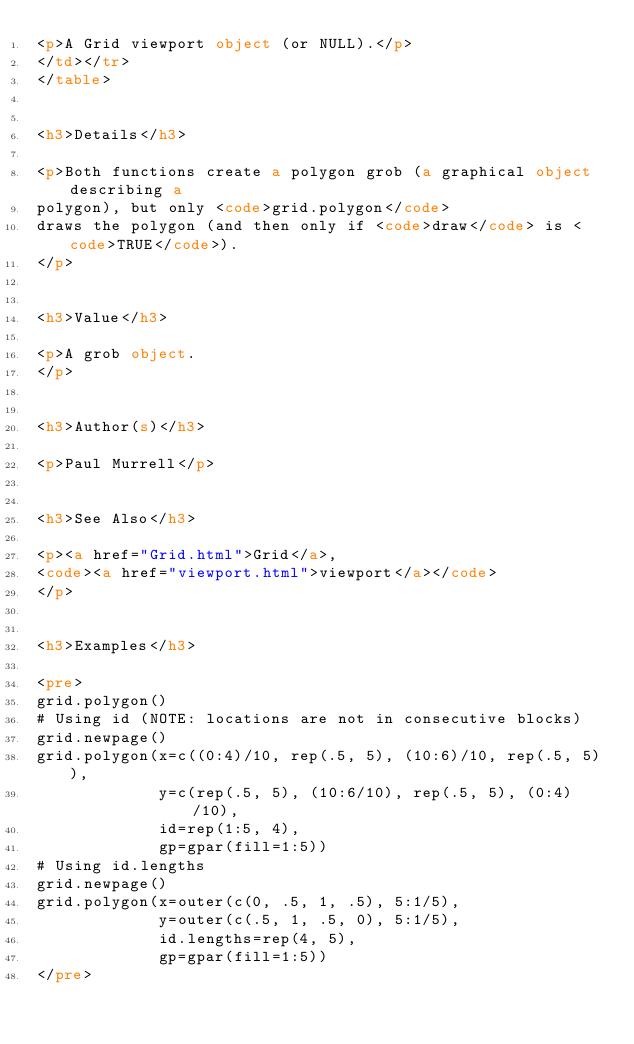Convert code to text. <code><loc_0><loc_0><loc_500><loc_500><_HTML_><p>A Grid viewport object (or NULL).</p>
</td></tr>
</table>


<h3>Details</h3>

<p>Both functions create a polygon grob (a graphical object describing a
polygon), but only <code>grid.polygon</code>
draws the polygon (and then only if <code>draw</code> is <code>TRUE</code>).
</p>


<h3>Value</h3>

<p>A grob object.
</p>


<h3>Author(s)</h3>

<p>Paul Murrell</p>


<h3>See Also</h3>

<p><a href="Grid.html">Grid</a>,
<code><a href="viewport.html">viewport</a></code>
</p>


<h3>Examples</h3>

<pre>
grid.polygon()
# Using id (NOTE: locations are not in consecutive blocks)
grid.newpage()
grid.polygon(x=c((0:4)/10, rep(.5, 5), (10:6)/10, rep(.5, 5)),
             y=c(rep(.5, 5), (10:6/10), rep(.5, 5), (0:4)/10),
             id=rep(1:5, 4),
             gp=gpar(fill=1:5))
# Using id.lengths
grid.newpage()
grid.polygon(x=outer(c(0, .5, 1, .5), 5:1/5),
             y=outer(c(.5, 1, .5, 0), 5:1/5),
             id.lengths=rep(4, 5),
             gp=gpar(fill=1:5))
</pre>
</code> 